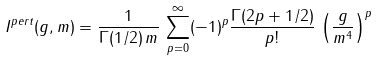<formula> <loc_0><loc_0><loc_500><loc_500>I ^ { p e r t } ( g , m ) = \frac { 1 } { \Gamma ( 1 / 2 ) \, m } \, \sum _ { p = 0 } ^ { \infty } ( - 1 ) ^ { p } \frac { \Gamma ( 2 p + 1 / 2 ) } { p ! } \, \left ( \frac { g } { m ^ { 4 } } \right ) ^ { p }</formula> 